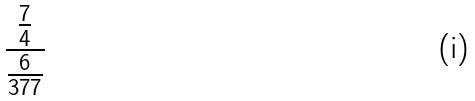<formula> <loc_0><loc_0><loc_500><loc_500>\frac { \frac { 7 } { 4 } } { \frac { 6 } { 3 7 7 } }</formula> 